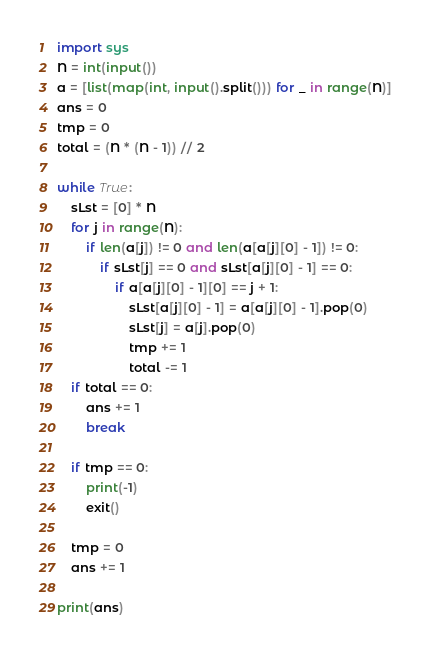<code> <loc_0><loc_0><loc_500><loc_500><_Python_>import sys
N = int(input())
a = [list(map(int, input().split())) for _ in range(N)]
ans = 0
tmp = 0
total = (N * (N - 1)) // 2

while True:
    sLst = [0] * N
    for j in range(N):
        if len(a[j]) != 0 and len(a[a[j][0] - 1]) != 0:
            if sLst[j] == 0 and sLst[a[j][0] - 1] == 0:
                if a[a[j][0] - 1][0] == j + 1:
                    sLst[a[j][0] - 1] = a[a[j][0] - 1].pop(0)
                    sLst[j] = a[j].pop(0)
                    tmp += 1
                    total -= 1
    if total == 0:
        ans += 1
        break

    if tmp == 0:
        print(-1)
        exit()

    tmp = 0
    ans += 1

print(ans)
</code> 